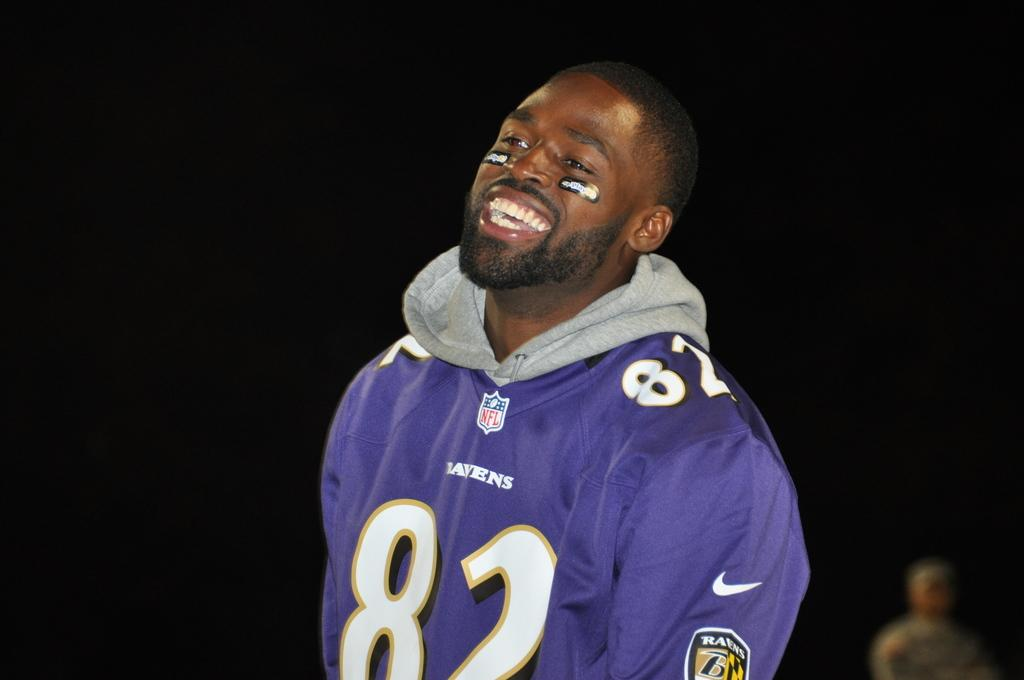<image>
Offer a succinct explanation of the picture presented. a laughing man in a purple 82 sports jersey 